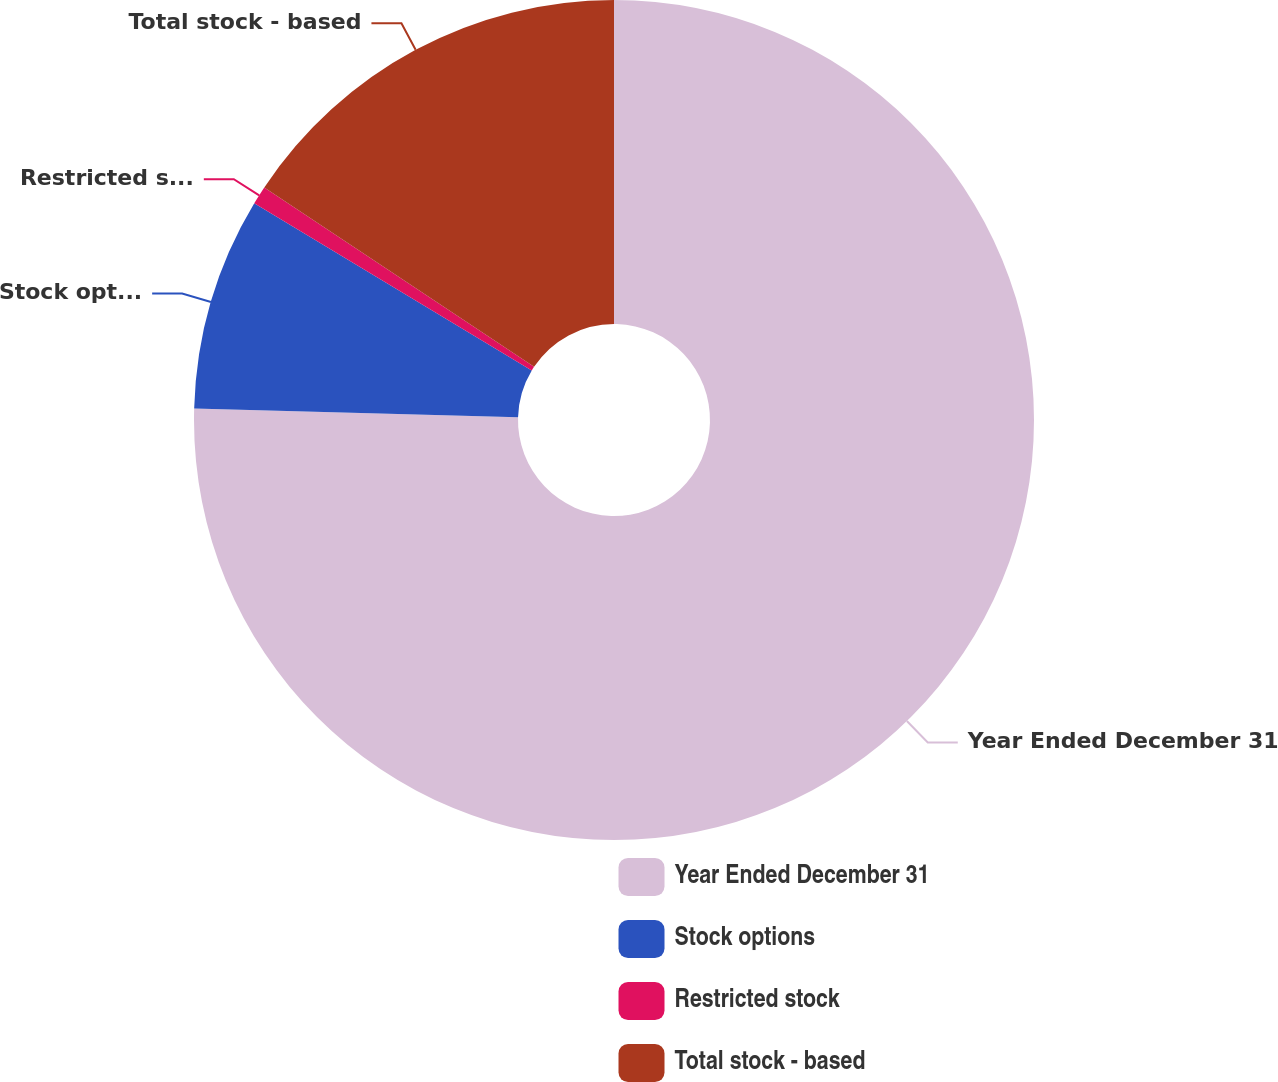Convert chart to OTSL. <chart><loc_0><loc_0><loc_500><loc_500><pie_chart><fcel>Year Ended December 31<fcel>Stock options<fcel>Restricted stock<fcel>Total stock - based<nl><fcel>75.44%<fcel>8.19%<fcel>0.71%<fcel>15.66%<nl></chart> 